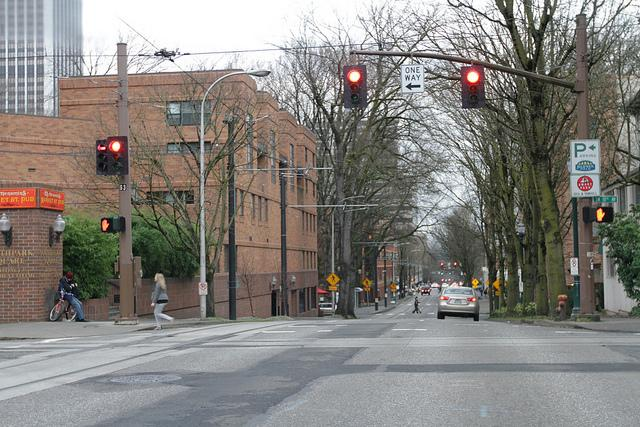Where do you think this is located? Please explain your reasoning. city. The area is located in an urban area. 